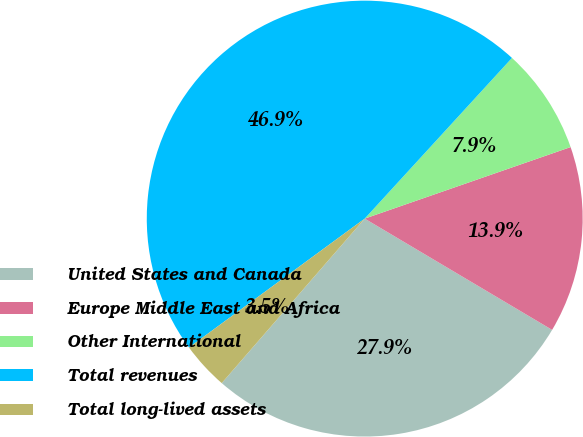<chart> <loc_0><loc_0><loc_500><loc_500><pie_chart><fcel>United States and Canada<fcel>Europe Middle East and Africa<fcel>Other International<fcel>Total revenues<fcel>Total long-lived assets<nl><fcel>27.86%<fcel>13.85%<fcel>7.87%<fcel>46.88%<fcel>3.54%<nl></chart> 